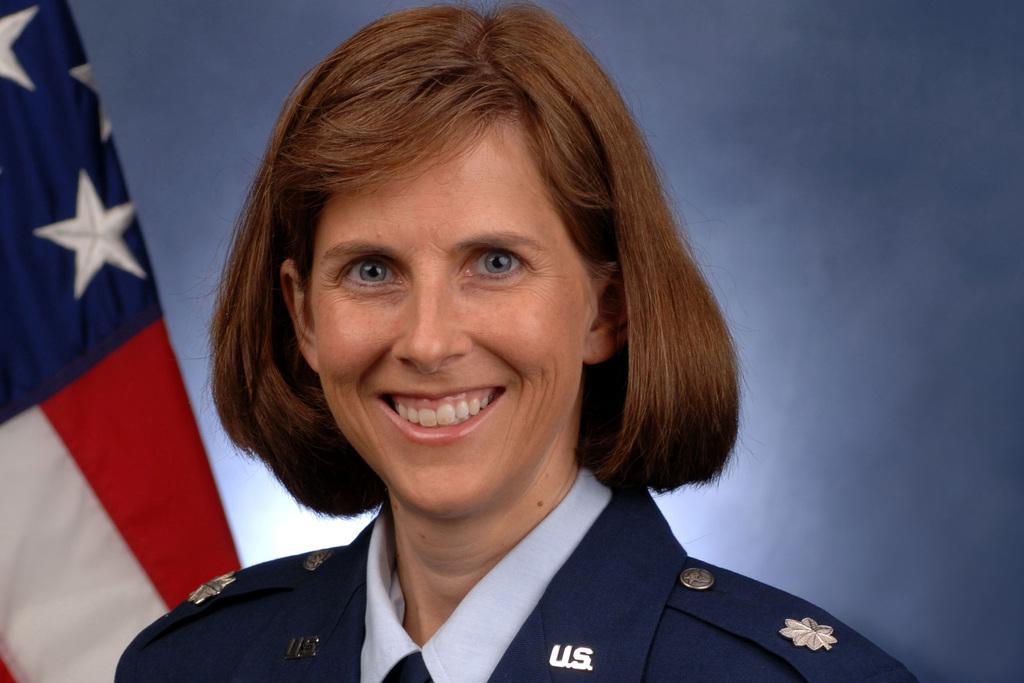How would you summarize this image in a sentence or two? In this image I can see the person with the uniform. In the background I can see the flag and there is a blue color background. 